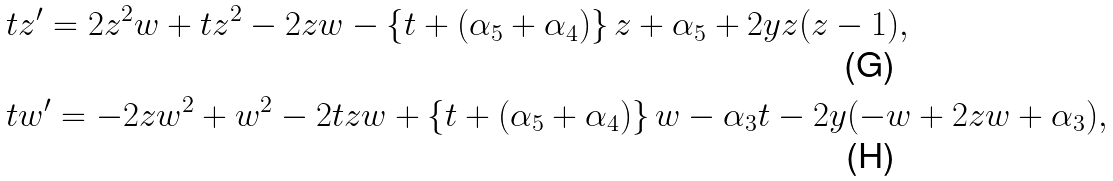<formula> <loc_0><loc_0><loc_500><loc_500>& t z ^ { \prime } = 2 z ^ { 2 } w + t z ^ { 2 } - 2 z w - \left \{ t + ( \alpha _ { 5 } + \alpha _ { 4 } ) \right \} z + \alpha _ { 5 } + 2 y z ( z - 1 ) , \\ & t w ^ { \prime } = - 2 z w ^ { 2 } + w ^ { 2 } - 2 t z w + \left \{ t + ( \alpha _ { 5 } + \alpha _ { 4 } ) \right \} w - \alpha _ { 3 } t - 2 y ( - w + 2 z w + \alpha _ { 3 } ) ,</formula> 